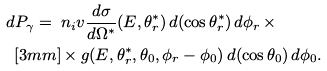<formula> <loc_0><loc_0><loc_500><loc_500>d P _ { \gamma } = \ & n _ { i } v \frac { d \sigma } { d \Omega ^ { * } } ( E , \theta _ { r } ^ { * } ) \, d ( \cos \theta _ { r } ^ { * } ) \, d \phi _ { r } \, \times \\ [ 3 m m ] & \times g ( E , \theta _ { r } ^ { * } , \theta _ { 0 } , \phi _ { r } - \phi _ { 0 } ) \, d ( \cos \theta _ { 0 } ) \, d \phi _ { 0 } .</formula> 